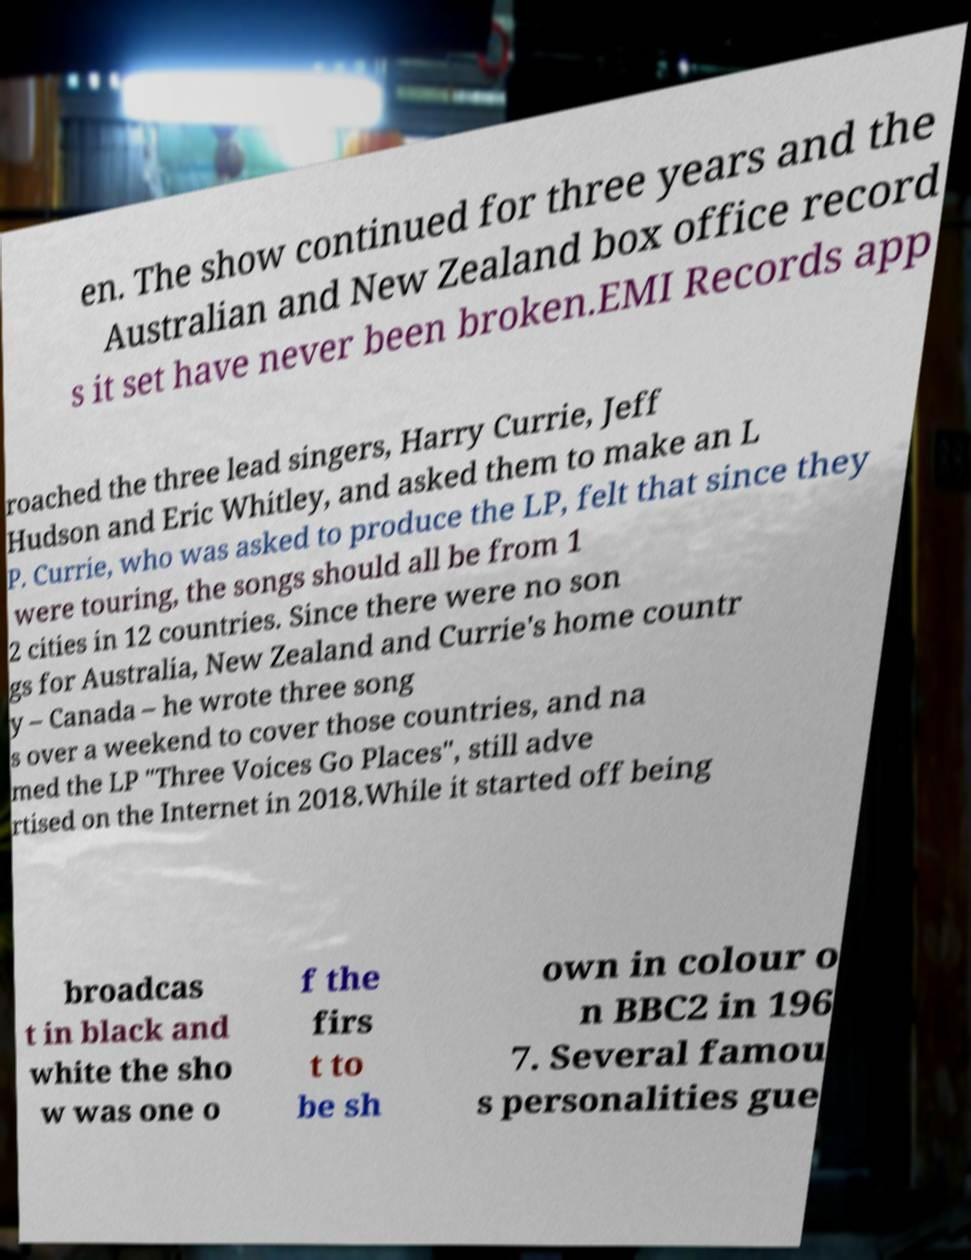For documentation purposes, I need the text within this image transcribed. Could you provide that? en. The show continued for three years and the Australian and New Zealand box office record s it set have never been broken.EMI Records app roached the three lead singers, Harry Currie, Jeff Hudson and Eric Whitley, and asked them to make an L P. Currie, who was asked to produce the LP, felt that since they were touring, the songs should all be from 1 2 cities in 12 countries. Since there were no son gs for Australia, New Zealand and Currie's home countr y – Canada – he wrote three song s over a weekend to cover those countries, and na med the LP "Three Voices Go Places", still adve rtised on the Internet in 2018.While it started off being broadcas t in black and white the sho w was one o f the firs t to be sh own in colour o n BBC2 in 196 7. Several famou s personalities gue 